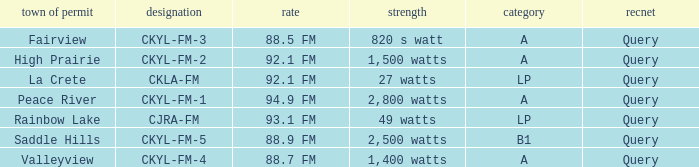Which city possesses a license for a 1,400 watts energy? Valleyview. 